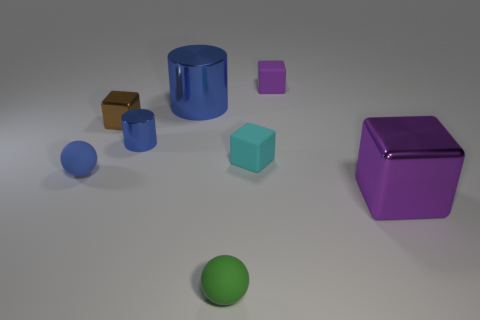What can you infer about the lighting in this scene? The lighting in this scene is soft and diffused, coming from above and casting gentle shadows beneath the objects. It's likely that there's a single broad light source above the objects, similar to a softbox in a photography studio, which creates an even illumination with a gradual transition between light and dark areas. 